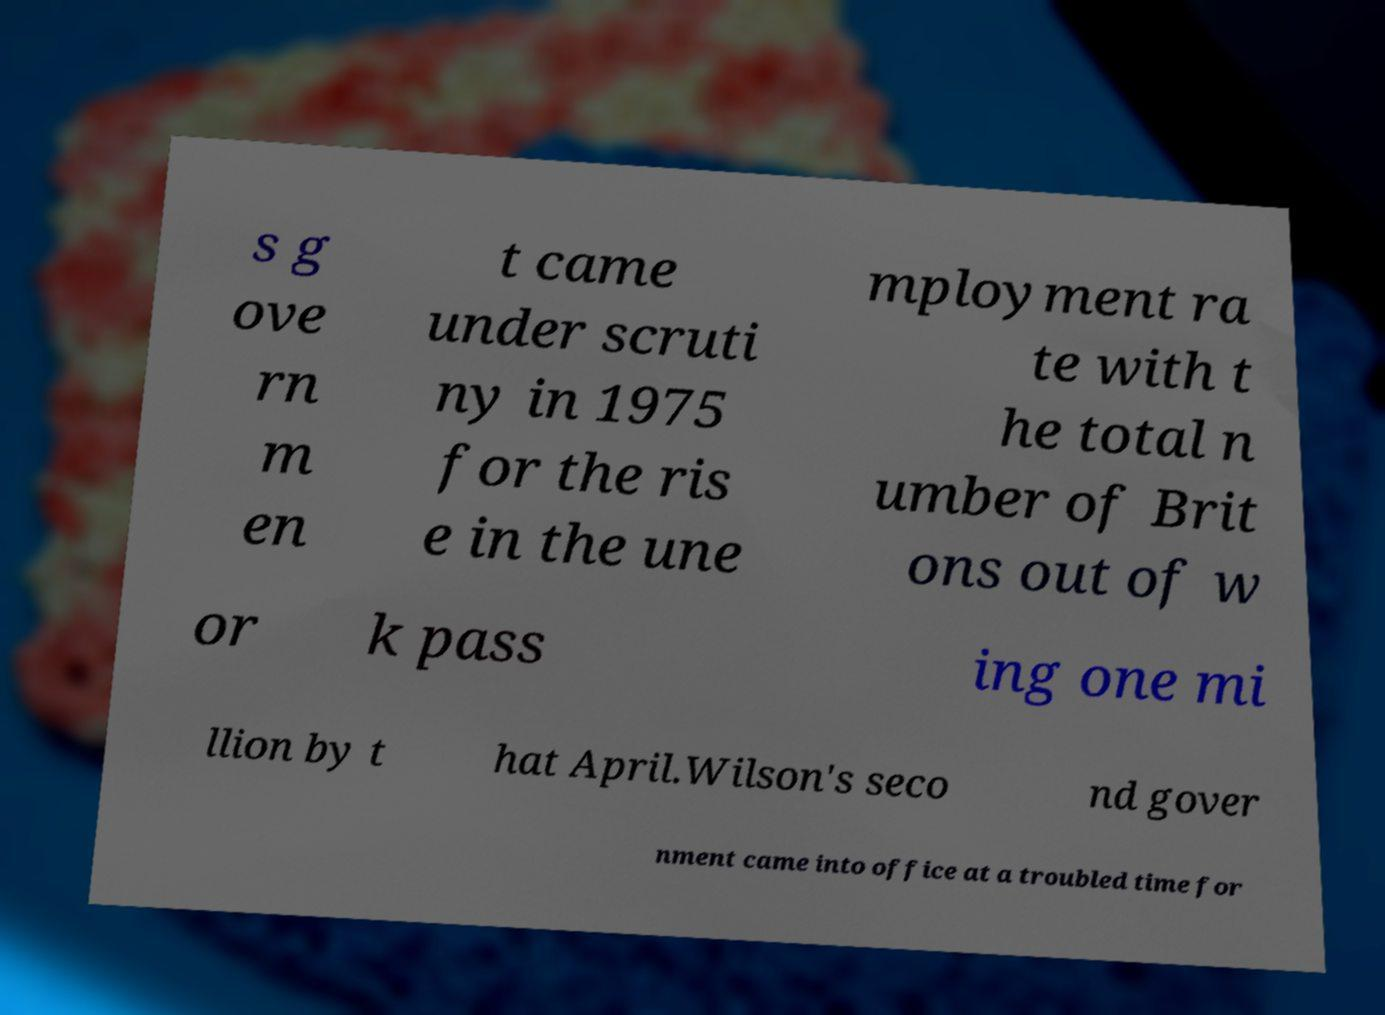There's text embedded in this image that I need extracted. Can you transcribe it verbatim? s g ove rn m en t came under scruti ny in 1975 for the ris e in the une mployment ra te with t he total n umber of Brit ons out of w or k pass ing one mi llion by t hat April.Wilson's seco nd gover nment came into office at a troubled time for 